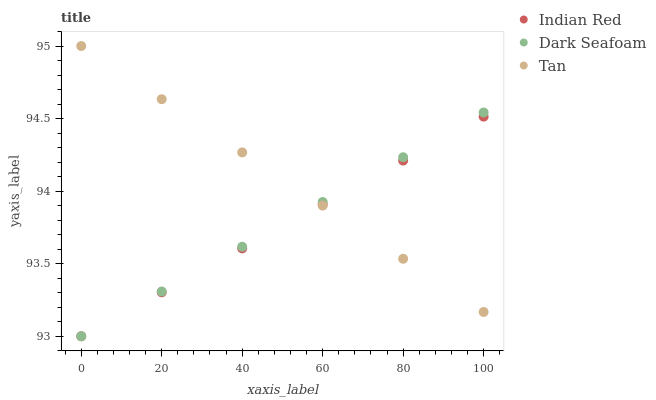Does Indian Red have the minimum area under the curve?
Answer yes or no. Yes. Does Tan have the maximum area under the curve?
Answer yes or no. Yes. Does Tan have the minimum area under the curve?
Answer yes or no. No. Does Indian Red have the maximum area under the curve?
Answer yes or no. No. Is Tan the smoothest?
Answer yes or no. Yes. Is Indian Red the roughest?
Answer yes or no. Yes. Is Indian Red the smoothest?
Answer yes or no. No. Is Tan the roughest?
Answer yes or no. No. Does Dark Seafoam have the lowest value?
Answer yes or no. Yes. Does Tan have the lowest value?
Answer yes or no. No. Does Tan have the highest value?
Answer yes or no. Yes. Does Indian Red have the highest value?
Answer yes or no. No. Does Tan intersect Dark Seafoam?
Answer yes or no. Yes. Is Tan less than Dark Seafoam?
Answer yes or no. No. Is Tan greater than Dark Seafoam?
Answer yes or no. No. 